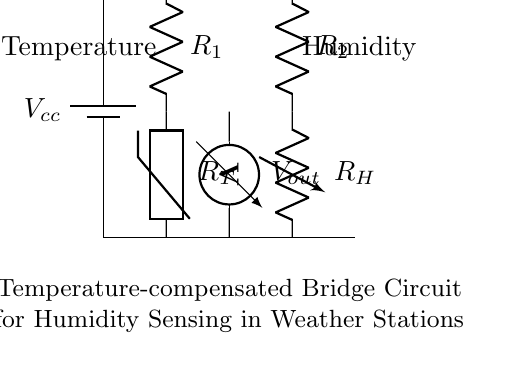What is the main purpose of this circuit? The main purpose of this circuit is to sense humidity while compensating for the effects of temperature variations, ensuring precise measurements in weather stations.
Answer: Humidity sensing What type of sensors are used in this bridge circuit? The circuit uses a thermistor and a variable resistor as components. The thermistor is sensitive to temperature, while the variable resistor adjusts for humidity changes.
Answer: Thermistor and variable resistor How many resistors are present in the circuit? The circuit contains two resistors: one fixed resistor, labeled as R1, and one variable resistor, labeled as R_H.
Answer: Two resistors What does the voltmeter measure in this circuit? The voltmeter measures the output voltage, V_out, which indicates the balance condition of the bridge and is relevant for determining humidity levels.
Answer: Output voltage How does the variable resistor affect the circuit? The variable resistor is adjusted to balance the bridge under different humidity conditions, allowing for accurate humidity readings by compensating for temperature changes measured by the thermistor.
Answer: Balances the bridge What component compensates for temperature variations in this circuit? The thermistor, which changes resistance with temperature, works in conjunction with the variable resistor to achieve temperature compensation and maintain precise readings.
Answer: Thermistor What is the symbol for the battery in this circuit? The symbol for the battery is represented as a long and short parallel line, indicating the positive and negative terminals of the voltage source, V_cc.
Answer: Long and short parallel lines 